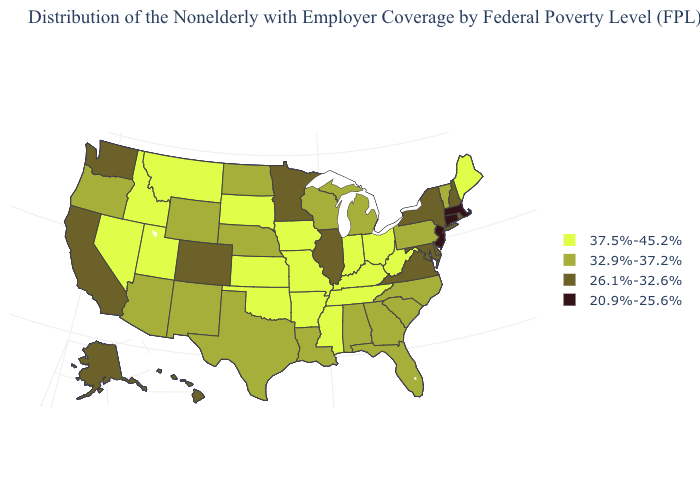Name the states that have a value in the range 20.9%-25.6%?
Quick response, please. Connecticut, Massachusetts, New Jersey. What is the value of Georgia?
Quick response, please. 32.9%-37.2%. What is the value of Mississippi?
Answer briefly. 37.5%-45.2%. Among the states that border Arizona , which have the highest value?
Write a very short answer. Nevada, Utah. Does the first symbol in the legend represent the smallest category?
Write a very short answer. No. Which states have the highest value in the USA?
Keep it brief. Arkansas, Idaho, Indiana, Iowa, Kansas, Kentucky, Maine, Mississippi, Missouri, Montana, Nevada, Ohio, Oklahoma, South Dakota, Tennessee, Utah, West Virginia. Does Michigan have a lower value than Tennessee?
Keep it brief. Yes. Which states have the lowest value in the South?
Short answer required. Delaware, Maryland, Virginia. What is the value of Illinois?
Concise answer only. 26.1%-32.6%. Does North Dakota have a higher value than New Hampshire?
Keep it brief. Yes. Which states have the lowest value in the Northeast?
Write a very short answer. Connecticut, Massachusetts, New Jersey. Name the states that have a value in the range 20.9%-25.6%?
Concise answer only. Connecticut, Massachusetts, New Jersey. What is the value of Illinois?
Write a very short answer. 26.1%-32.6%. Does the map have missing data?
Keep it brief. No. How many symbols are there in the legend?
Concise answer only. 4. 